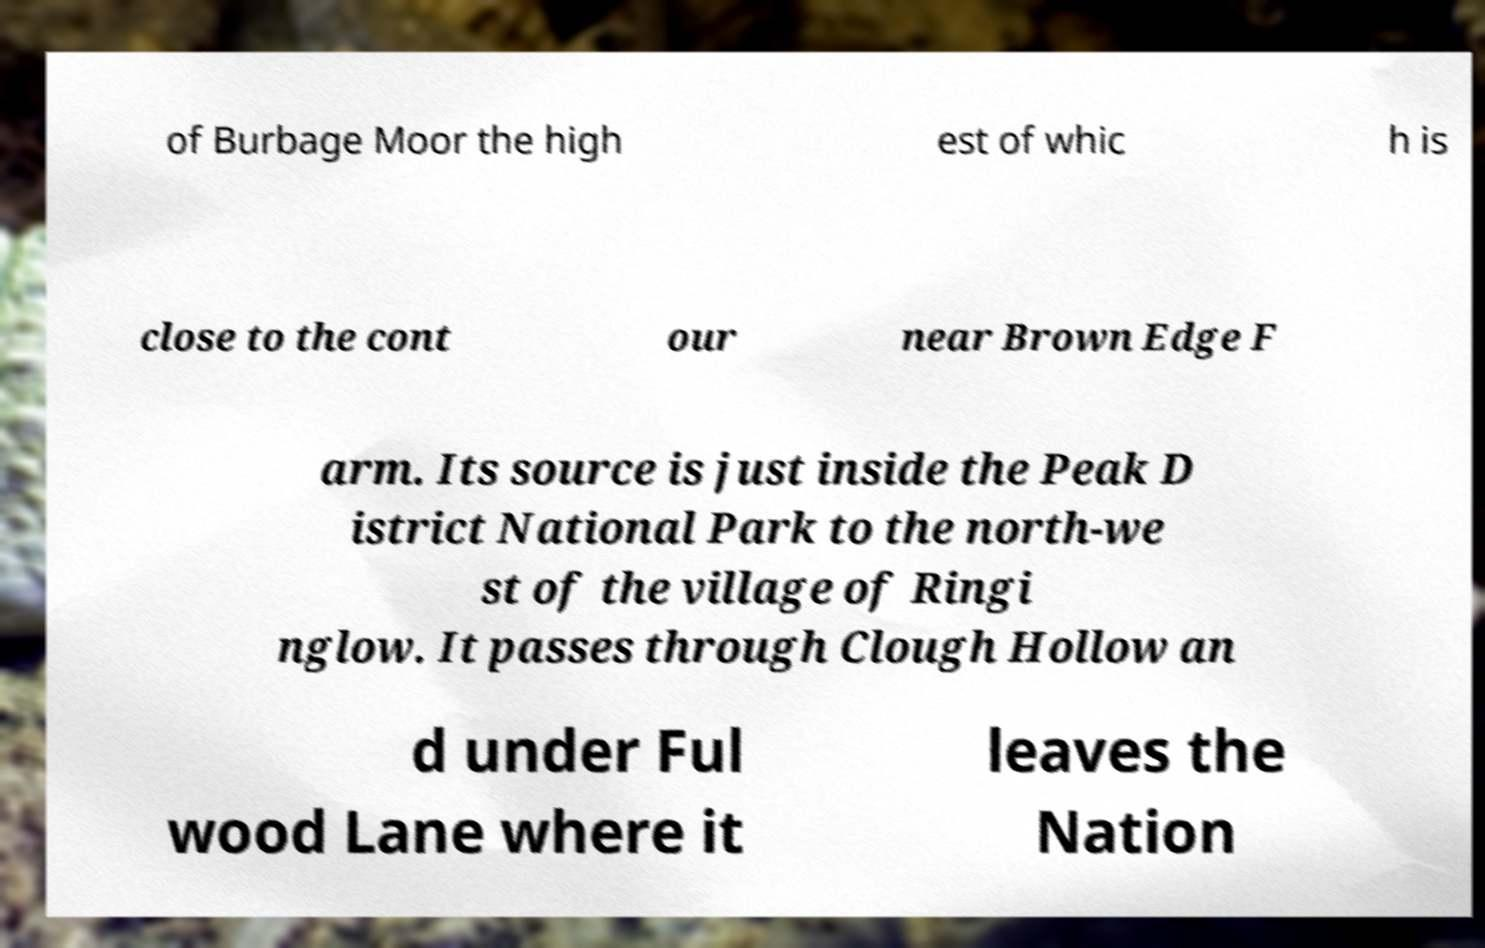Please identify and transcribe the text found in this image. of Burbage Moor the high est of whic h is close to the cont our near Brown Edge F arm. Its source is just inside the Peak D istrict National Park to the north-we st of the village of Ringi nglow. It passes through Clough Hollow an d under Ful wood Lane where it leaves the Nation 